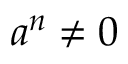Convert formula to latex. <formula><loc_0><loc_0><loc_500><loc_500>a ^ { n } \neq 0</formula> 